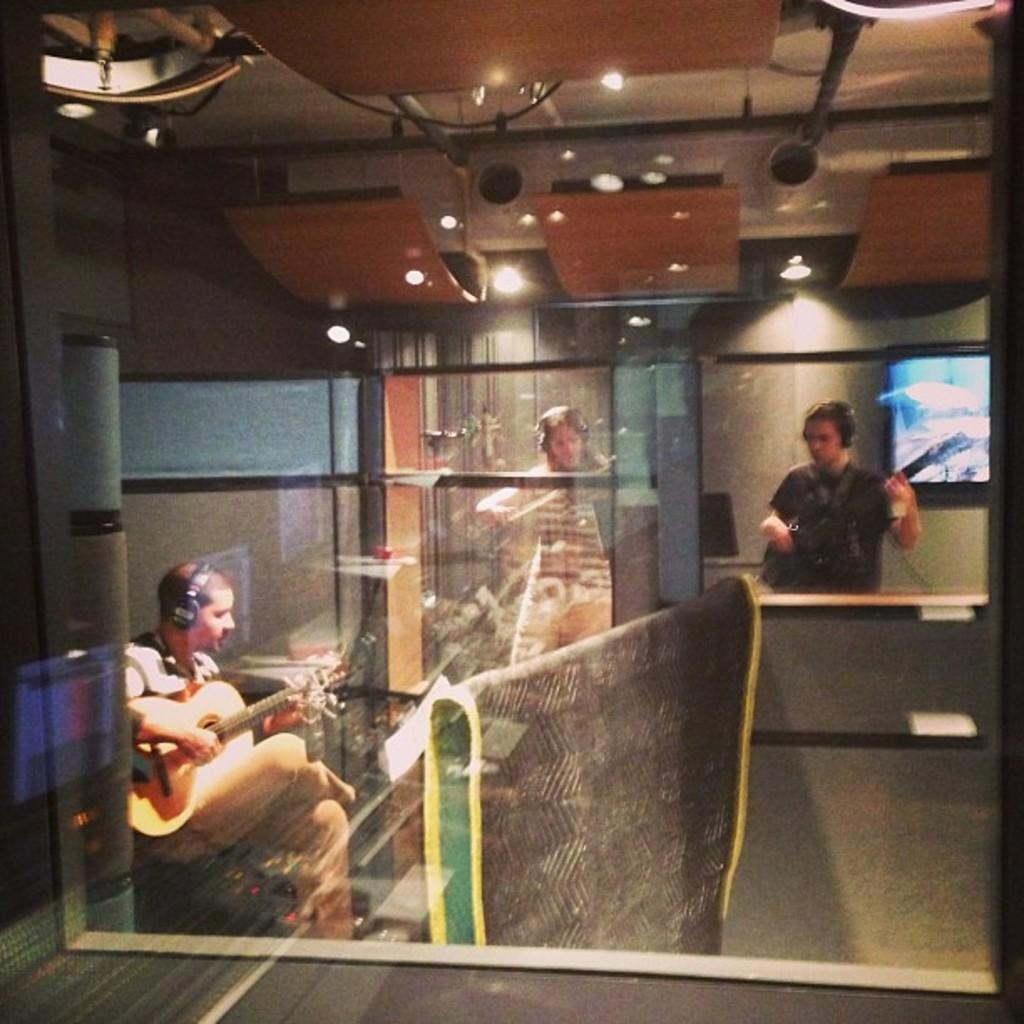How many men are in the image? There are three men in the image. What are the men doing in the image? The men are playing guitars. Can you describe the positions of the men in the image? Some of the men are sitting, while others are standing. What can be seen in the background of the image? There is a screen, a glass object, and a light source in the background of the image. What type of pipe can be seen in the image? There is no pipe present in the image. What topic are the men discussing while playing guitars? The image does not show any discussion taking place, as the men are focused on playing their guitars. 